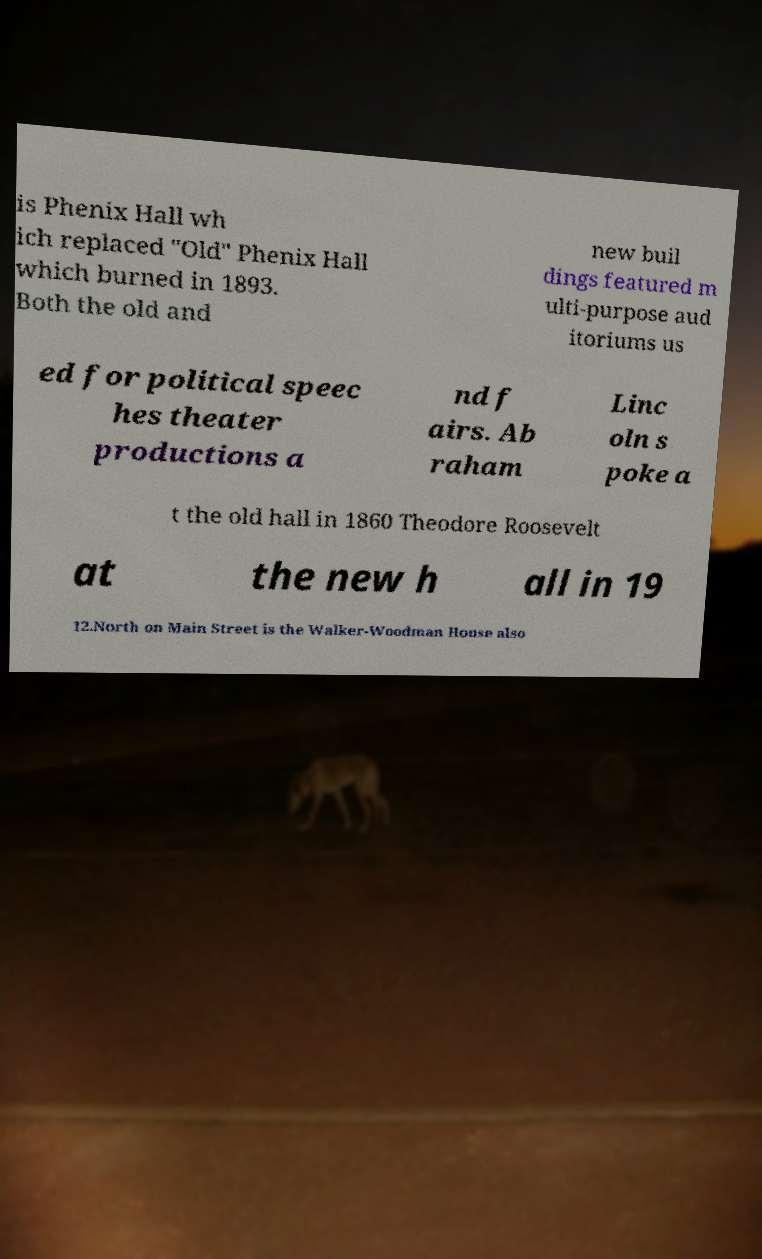Could you extract and type out the text from this image? is Phenix Hall wh ich replaced "Old" Phenix Hall which burned in 1893. Both the old and new buil dings featured m ulti-purpose aud itoriums us ed for political speec hes theater productions a nd f airs. Ab raham Linc oln s poke a t the old hall in 1860 Theodore Roosevelt at the new h all in 19 12.North on Main Street is the Walker-Woodman House also 